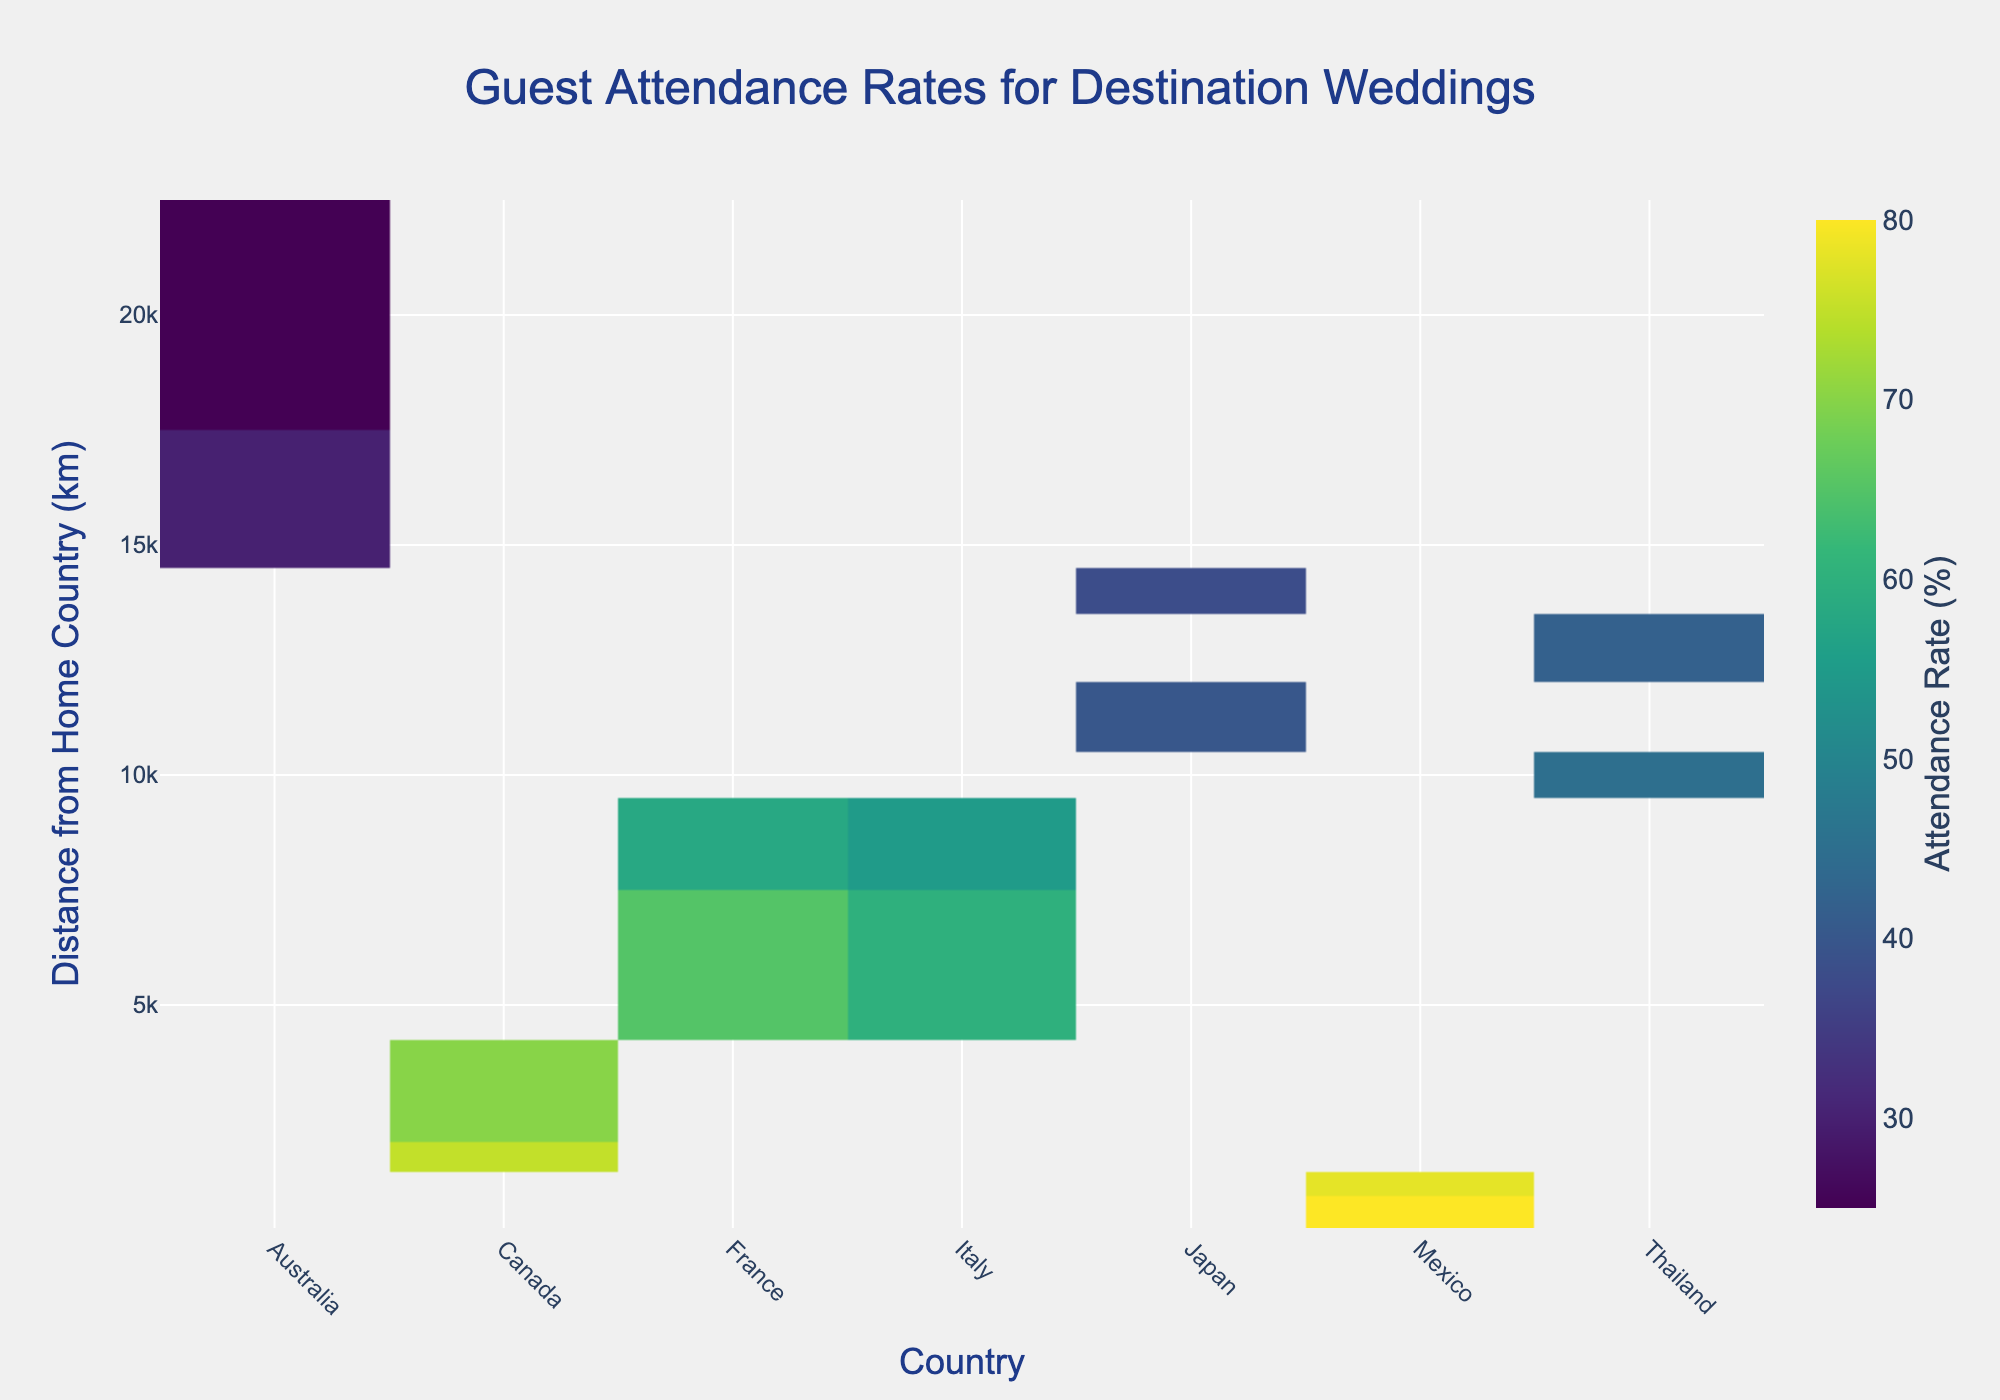What is the attendance rate for Mexico at a distance of 500 km? Locate the cell in the heatmap where the country is Mexico and the distance is 500 km. The value in that cell represents the attendance rate.
Answer: 80% Which country has the lowest attendance rate at the max distance shown? Identify the maximum distance from the y-axis, then find the country with the lowest attendance rate at that distance.
Answer: Australia Does guest attendance generally decrease as the distance from the home country increases? Observe the variation in attendance rates across countries as the distance from the home country increases on the y-axis. Typically, attendance rates decrease with increasing distance.
Answer: Yes What is the attendance rate range for France? Locate all the France data points and note their attendance rates. The range is the difference between the highest and lowest rates for France.
Answer: 65% to 58% Which country has more consistent attendance rates given different distances? Compare the variations in attendance rates for each country across different distances. The country with the least variation is the most consistent.
Answer: Mexico What is the average attendance rate for Canada across all distances? Find all the attendance rates for Canada and calculate their average. (75% + 70%) / 2 = 72.5%
Answer: 72.5% How does the attendance rate for a wedding in Thailand at 13,000 km compare to one in Italy at 9,000 km? Locate the attendance rates for Thailand at 13,000 km and Italy at 9,000 km and compare. Thailand has 42%, and Italy has 55%, so Thailand has a lower rate.
Answer: Thailand is lower Which country shows the highest attendance rate at a distance of 6000 km? Locate the cell at 6000 km and compare the attendance rates for all countries at that distance.
Answer: France Are there any countries with multiple entries at different distances? Look for countries that appear more than once in the x-axis categories and note their distances.
Answer: Mexico and Canada What is the median attendance rate for all listed events in Japan? Find all attendance rates for Japan and determine the median value. Rates are 40% and 38%, so the median is the average of these two values. (40% + 38%) / 2 = 39%
Answer: 39% 